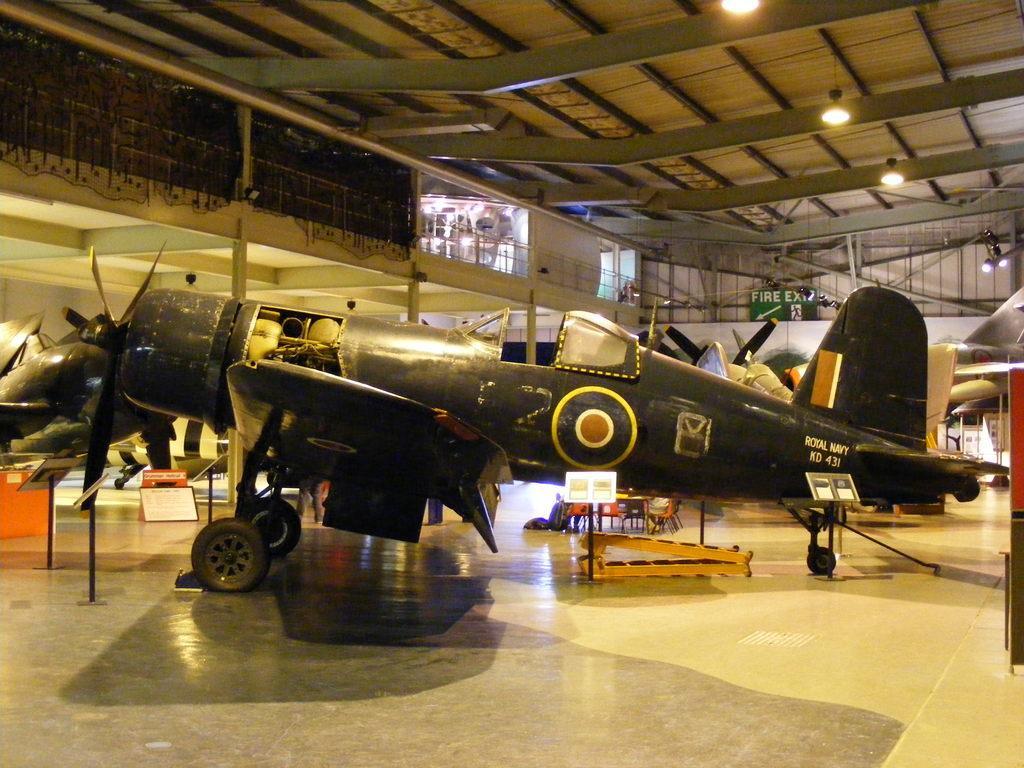Could you give a brief overview of what you see in this image? In this image I can see many aircrafts inside the shed. To the side of these aircraft's I can see some boards. In the background I can see the green color board and many lights in the top. 